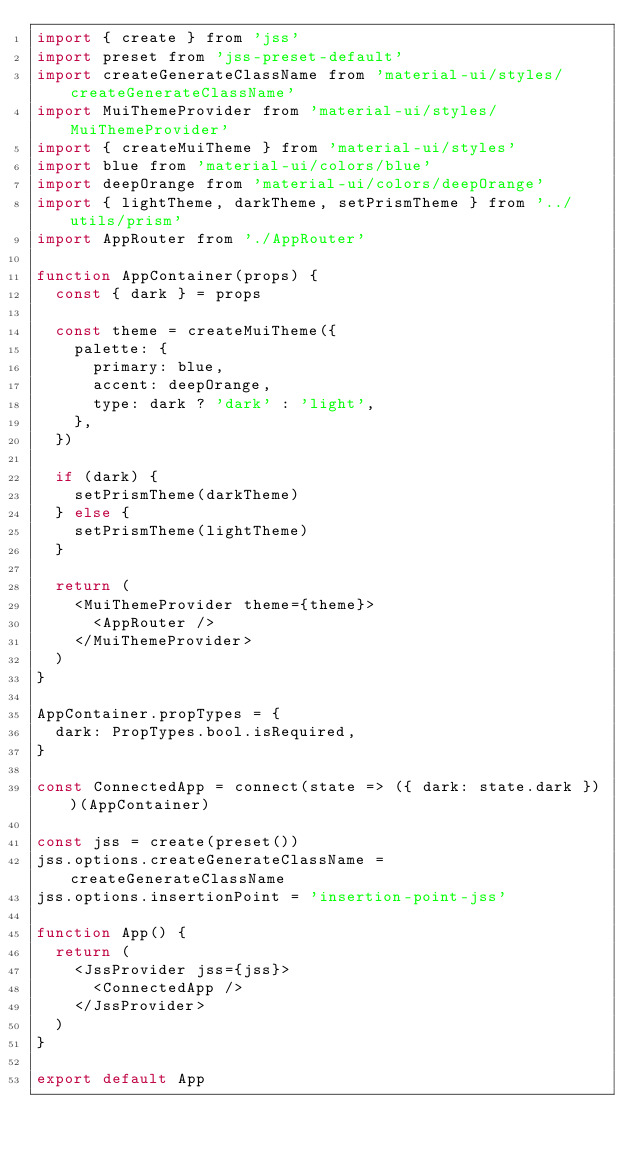Convert code to text. <code><loc_0><loc_0><loc_500><loc_500><_JavaScript_>import { create } from 'jss'
import preset from 'jss-preset-default'
import createGenerateClassName from 'material-ui/styles/createGenerateClassName'
import MuiThemeProvider from 'material-ui/styles/MuiThemeProvider'
import { createMuiTheme } from 'material-ui/styles'
import blue from 'material-ui/colors/blue'
import deepOrange from 'material-ui/colors/deepOrange'
import { lightTheme, darkTheme, setPrismTheme } from '../utils/prism'
import AppRouter from './AppRouter'

function AppContainer(props) {
  const { dark } = props

  const theme = createMuiTheme({
    palette: {
      primary: blue,
      accent: deepOrange,
      type: dark ? 'dark' : 'light',
    },
  })

  if (dark) {
    setPrismTheme(darkTheme)
  } else {
    setPrismTheme(lightTheme)
  }

  return (
    <MuiThemeProvider theme={theme}>
      <AppRouter />
    </MuiThemeProvider>
  )
}

AppContainer.propTypes = {
  dark: PropTypes.bool.isRequired,
}

const ConnectedApp = connect(state => ({ dark: state.dark }))(AppContainer)

const jss = create(preset())
jss.options.createGenerateClassName = createGenerateClassName
jss.options.insertionPoint = 'insertion-point-jss'

function App() {
  return (
    <JssProvider jss={jss}>
      <ConnectedApp />
    </JssProvider>
  )
}

export default App
</code> 